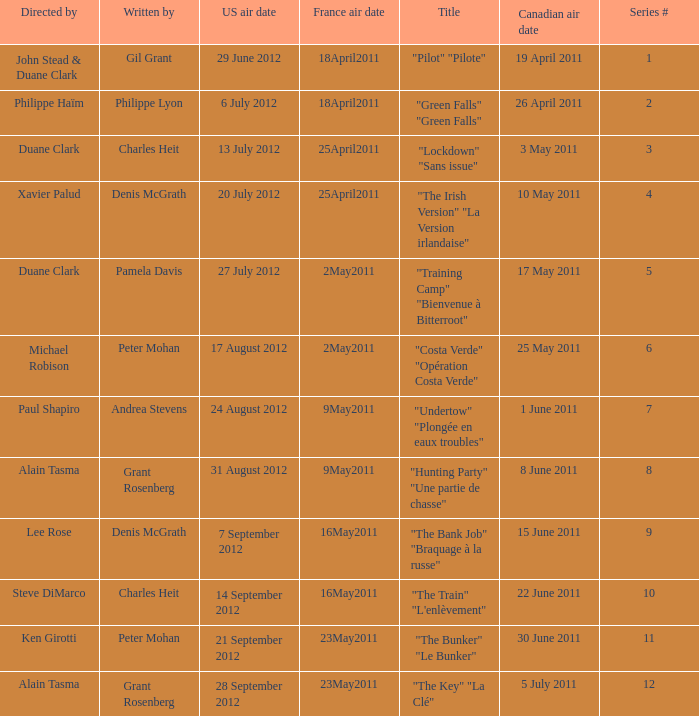What is the canadian air date when the US air date is 24 august 2012? 1 June 2011. 